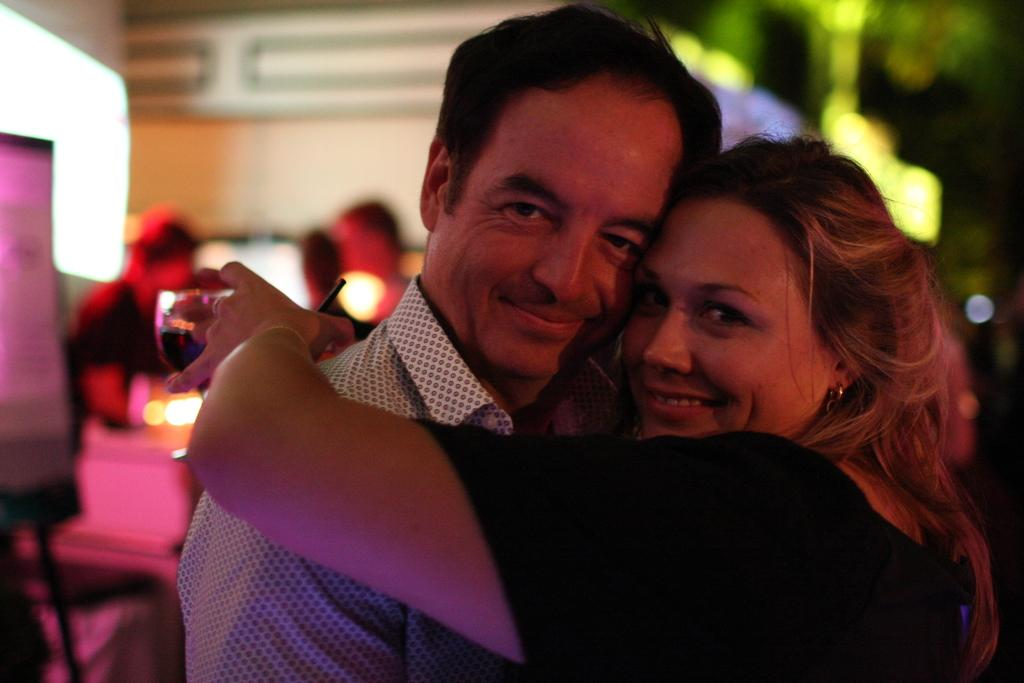How many people are in the image? There are two people in the image. What are the two people doing? The two people are hugging and posing for a picture. What is one of the people holding? One of the people is holding a glass. What can be seen in the background of the image? There are people and other objects in the background of the image. What type of ear can be seen on the person holding the glass in the image? There is no ear visible on the person holding the glass in the image. What is the temperature of the hot object in the image? There is no hot object present in the image. 